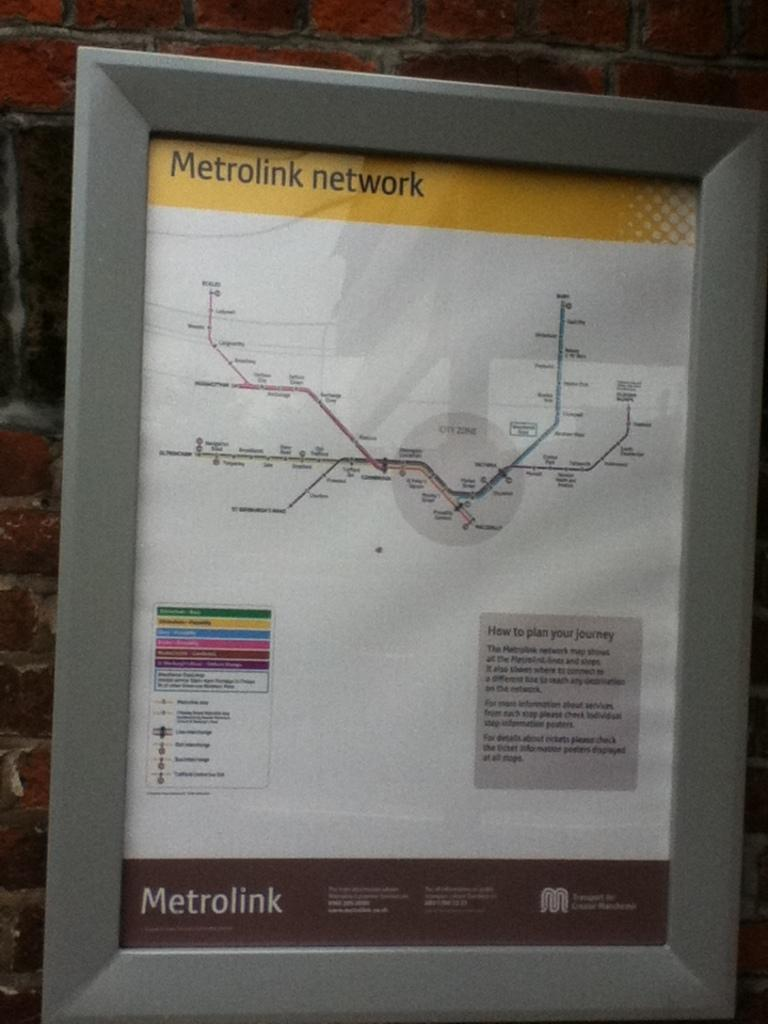<image>
Provide a brief description of the given image. A framed diagram of the routes on the Metrolink network. 